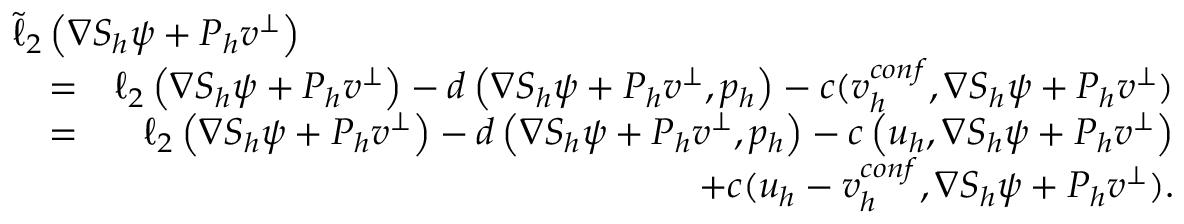<formula> <loc_0><loc_0><loc_500><loc_500>\begin{array} { r l r } { { \tilde { \ell } _ { 2 } \left ( \nabla S _ { h } \psi + P _ { h } v ^ { \bot } \right ) } } \\ & { = } & { \ell _ { 2 } \left ( \nabla S _ { h } \psi + P _ { h } v ^ { \bot } \right ) - d \left ( \nabla S _ { h } \psi + P _ { h } v ^ { \bot } , { p } _ { h } \right ) - c ( v _ { h } ^ { c o n f } , \nabla S _ { h } \psi + P _ { h } v ^ { \bot } ) } \\ & { = } & { \ell _ { 2 } \left ( \nabla S _ { h } \psi + P _ { h } v ^ { \bot } \right ) - d \left ( \nabla S _ { h } \psi + P _ { h } v ^ { \bot } , { p } _ { h } \right ) - c \left ( u _ { h } , \nabla S _ { h } \psi + P _ { h } v ^ { \bot } \right ) } \\ & { + c ( u _ { h } - v _ { h } ^ { c o n f } , \nabla S _ { h } \psi + P _ { h } v ^ { \bot } ) . } \end{array}</formula> 